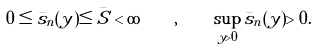<formula> <loc_0><loc_0><loc_500><loc_500>0 \leq \bar { s } _ { n } ( y ) \leq \bar { S } < \infty \quad , \quad \sup _ { y > 0 } \bar { s } _ { n } ( y ) > 0 .</formula> 